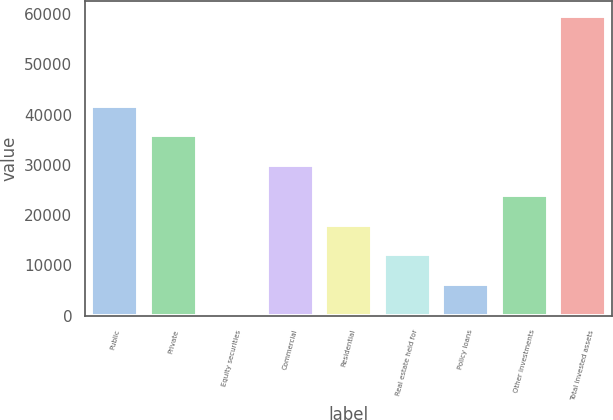<chart> <loc_0><loc_0><loc_500><loc_500><bar_chart><fcel>Public<fcel>Private<fcel>Equity securities<fcel>Commercial<fcel>Residential<fcel>Real estate held for<fcel>Policy loans<fcel>Other investments<fcel>Total invested assets<nl><fcel>41772.9<fcel>35860.9<fcel>388.8<fcel>29948.8<fcel>18124.8<fcel>12212.8<fcel>6300.81<fcel>24036.8<fcel>59508.9<nl></chart> 